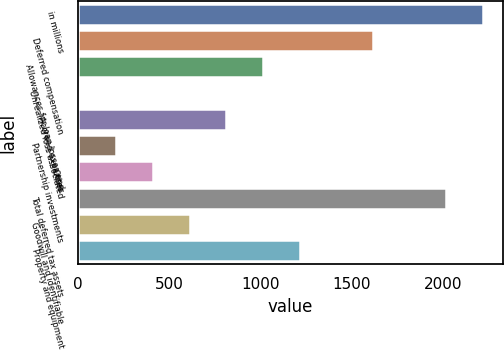<chart> <loc_0><loc_0><loc_500><loc_500><bar_chart><fcel>in millions<fcel>Deferred compensation<fcel>Allowances for loan losses and<fcel>Unrealized loss associated<fcel>Accrued expenses<fcel>Partnership investments<fcel>Other<fcel>Total deferred tax assets<fcel>Goodwill and identifiable<fcel>Property and equipment<nl><fcel>2219.9<fcel>1617.2<fcel>1014.5<fcel>10<fcel>813.6<fcel>210.9<fcel>411.8<fcel>2019<fcel>612.7<fcel>1215.4<nl></chart> 